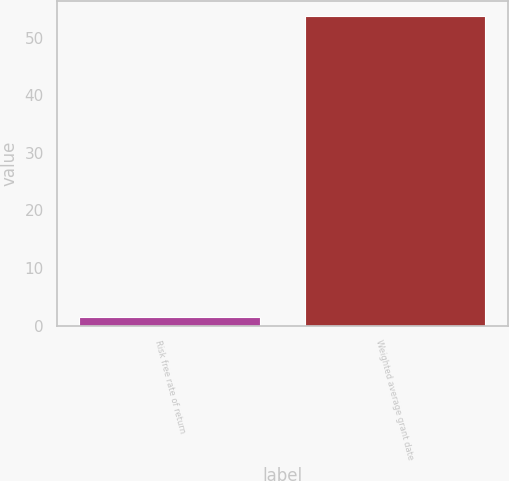<chart> <loc_0><loc_0><loc_500><loc_500><bar_chart><fcel>Risk free rate of return<fcel>Weighted average grant date<nl><fcel>1.53<fcel>53.73<nl></chart> 